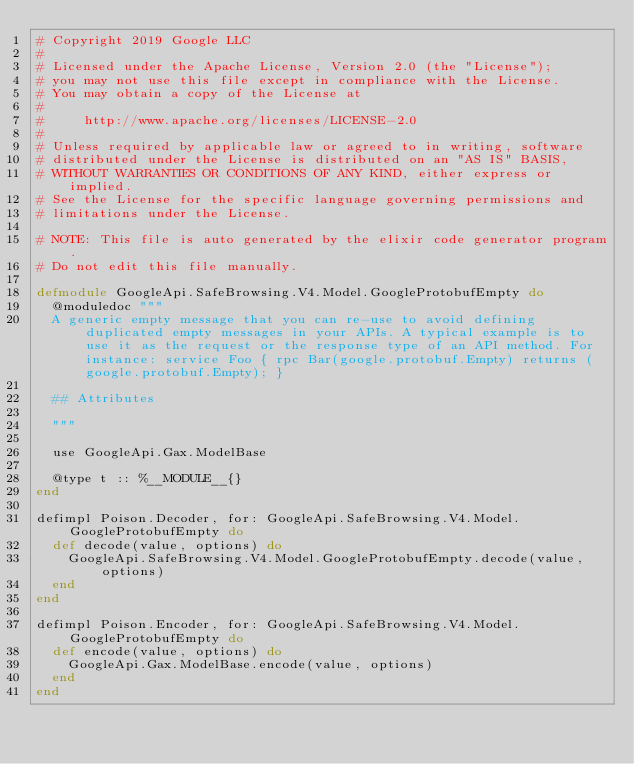<code> <loc_0><loc_0><loc_500><loc_500><_Elixir_># Copyright 2019 Google LLC
#
# Licensed under the Apache License, Version 2.0 (the "License");
# you may not use this file except in compliance with the License.
# You may obtain a copy of the License at
#
#     http://www.apache.org/licenses/LICENSE-2.0
#
# Unless required by applicable law or agreed to in writing, software
# distributed under the License is distributed on an "AS IS" BASIS,
# WITHOUT WARRANTIES OR CONDITIONS OF ANY KIND, either express or implied.
# See the License for the specific language governing permissions and
# limitations under the License.

# NOTE: This file is auto generated by the elixir code generator program.
# Do not edit this file manually.

defmodule GoogleApi.SafeBrowsing.V4.Model.GoogleProtobufEmpty do
  @moduledoc """
  A generic empty message that you can re-use to avoid defining duplicated empty messages in your APIs. A typical example is to use it as the request or the response type of an API method. For instance: service Foo { rpc Bar(google.protobuf.Empty) returns (google.protobuf.Empty); }

  ## Attributes

  """

  use GoogleApi.Gax.ModelBase

  @type t :: %__MODULE__{}
end

defimpl Poison.Decoder, for: GoogleApi.SafeBrowsing.V4.Model.GoogleProtobufEmpty do
  def decode(value, options) do
    GoogleApi.SafeBrowsing.V4.Model.GoogleProtobufEmpty.decode(value, options)
  end
end

defimpl Poison.Encoder, for: GoogleApi.SafeBrowsing.V4.Model.GoogleProtobufEmpty do
  def encode(value, options) do
    GoogleApi.Gax.ModelBase.encode(value, options)
  end
end
</code> 